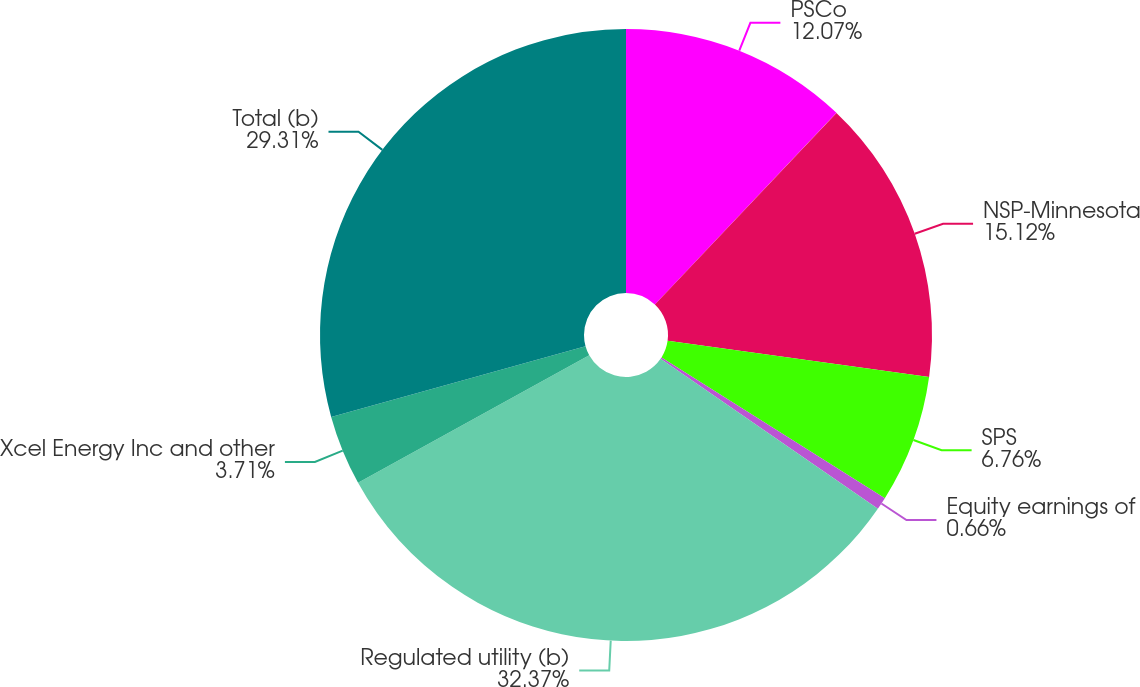<chart> <loc_0><loc_0><loc_500><loc_500><pie_chart><fcel>PSCo<fcel>NSP-Minnesota<fcel>SPS<fcel>Equity earnings of<fcel>Regulated utility (b)<fcel>Xcel Energy Inc and other<fcel>Total (b)<nl><fcel>12.07%<fcel>15.12%<fcel>6.76%<fcel>0.66%<fcel>32.36%<fcel>3.71%<fcel>29.31%<nl></chart> 